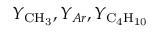<formula> <loc_0><loc_0><loc_500><loc_500>Y _ { { C H _ { 3 } } } , Y _ { A r } , Y _ { { C _ { 4 } H _ { 1 0 } } }</formula> 